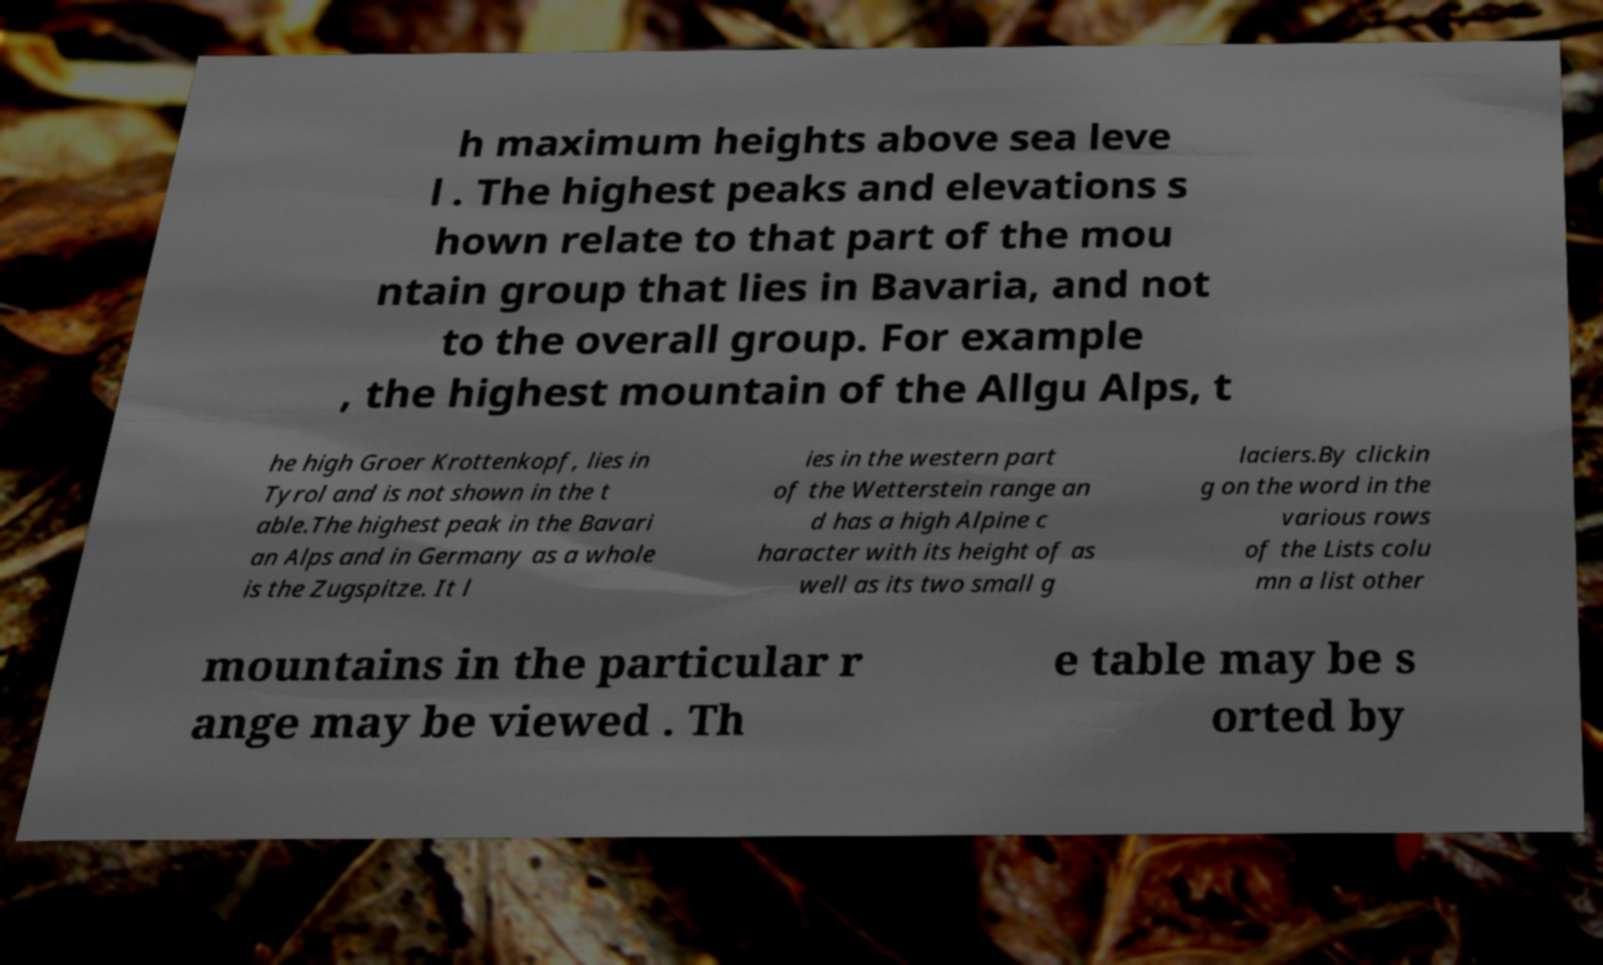For documentation purposes, I need the text within this image transcribed. Could you provide that? h maximum heights above sea leve l . The highest peaks and elevations s hown relate to that part of the mou ntain group that lies in Bavaria, and not to the overall group. For example , the highest mountain of the Allgu Alps, t he high Groer Krottenkopf, lies in Tyrol and is not shown in the t able.The highest peak in the Bavari an Alps and in Germany as a whole is the Zugspitze. It l ies in the western part of the Wetterstein range an d has a high Alpine c haracter with its height of as well as its two small g laciers.By clickin g on the word in the various rows of the Lists colu mn a list other mountains in the particular r ange may be viewed . Th e table may be s orted by 